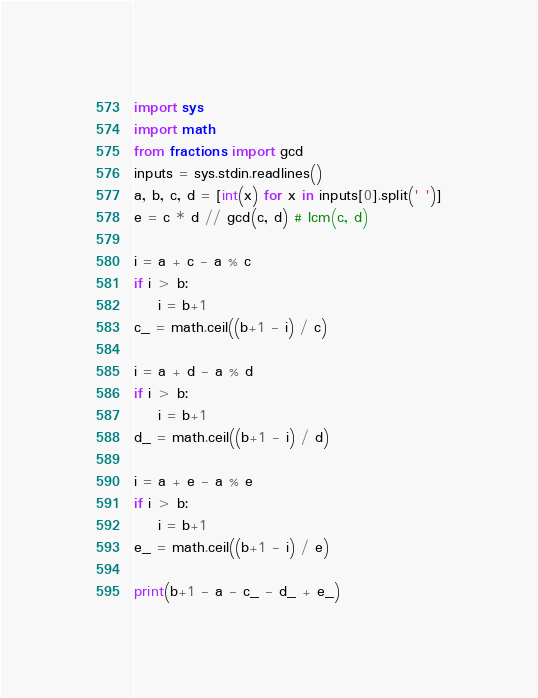Convert code to text. <code><loc_0><loc_0><loc_500><loc_500><_Python_>import sys
import math
from fractions import gcd
inputs = sys.stdin.readlines()
a, b, c, d = [int(x) for x in inputs[0].split(' ')]
e = c * d // gcd(c, d) # lcm(c, d)

i = a + c - a % c
if i > b:
    i = b+1
c_ = math.ceil((b+1 - i) / c)

i = a + d - a % d
if i > b:
    i = b+1
d_ = math.ceil((b+1 - i) / d)
    
i = a + e - a % e
if i > b:
    i = b+1
e_ = math.ceil((b+1 - i) / e)

print(b+1 - a - c_ - d_ + e_)</code> 